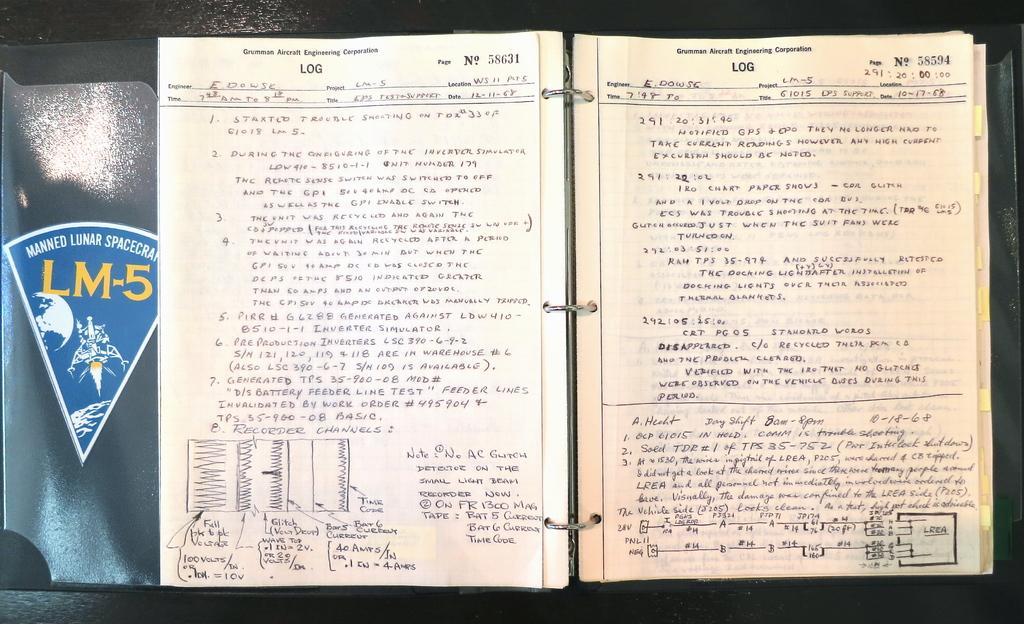<image>
Write a terse but informative summary of the picture. An open Gruman Aircraft Engineering logbook is filled with notes. 